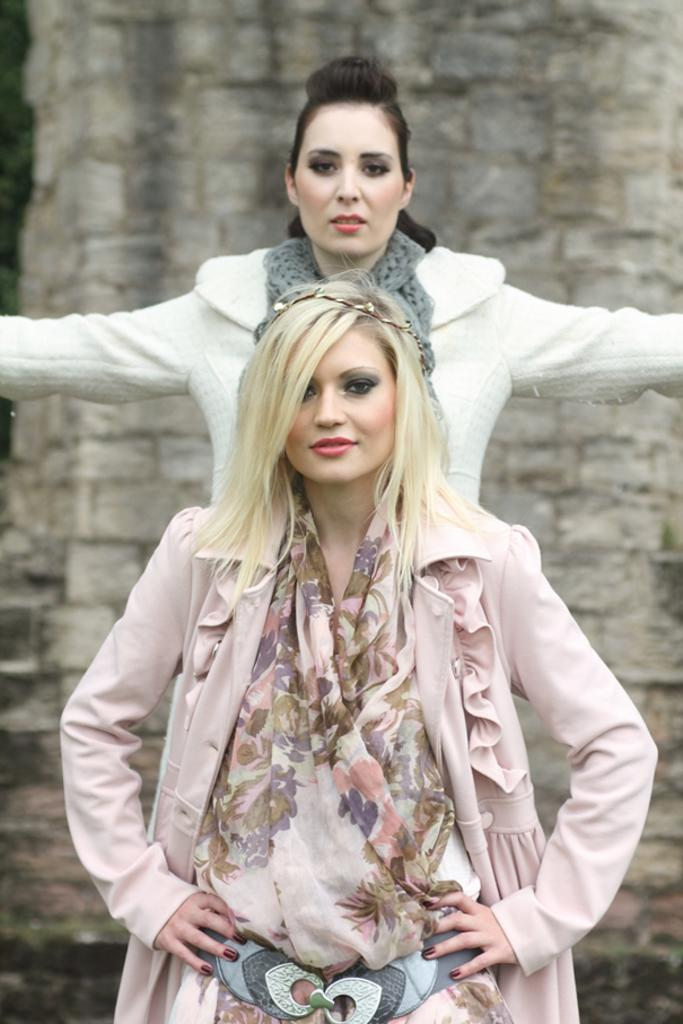How many women are in the image? There are two women in the image. Can you describe the woman in the foreground? The woman in the foreground appears beautiful and is looking at something. What is the other woman in the image doing? The other woman in the background is stretching her hands. What type of root can be seen growing in the image? There is no root visible in the image. 